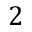Convert formula to latex. <formula><loc_0><loc_0><loc_500><loc_500>2</formula> 